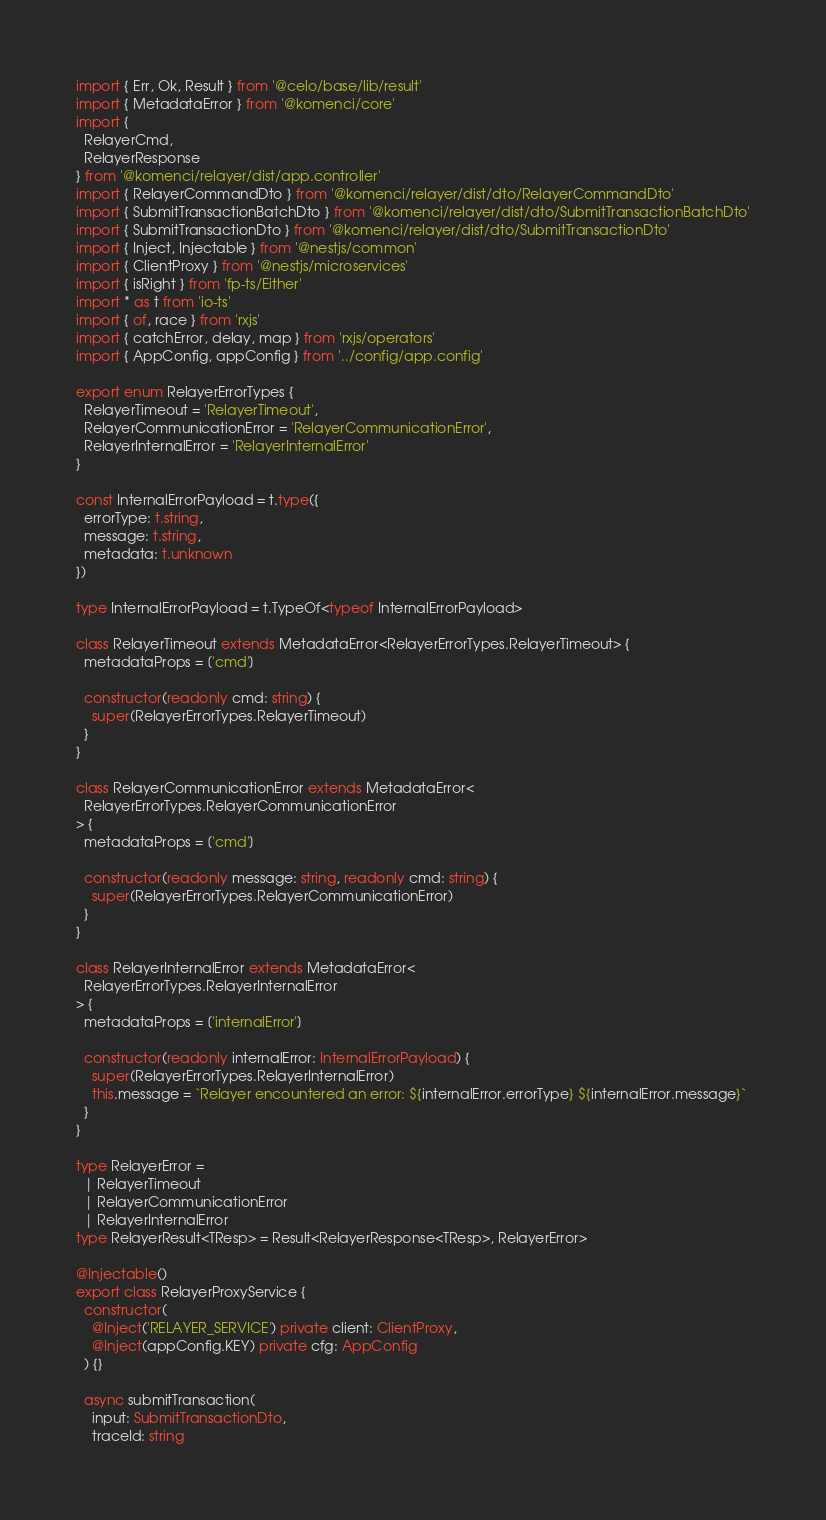Convert code to text. <code><loc_0><loc_0><loc_500><loc_500><_TypeScript_>import { Err, Ok, Result } from '@celo/base/lib/result'
import { MetadataError } from '@komenci/core'
import {
  RelayerCmd,
  RelayerResponse
} from '@komenci/relayer/dist/app.controller'
import { RelayerCommandDto } from '@komenci/relayer/dist/dto/RelayerCommandDto'
import { SubmitTransactionBatchDto } from '@komenci/relayer/dist/dto/SubmitTransactionBatchDto'
import { SubmitTransactionDto } from '@komenci/relayer/dist/dto/SubmitTransactionDto'
import { Inject, Injectable } from '@nestjs/common'
import { ClientProxy } from '@nestjs/microservices'
import { isRight } from 'fp-ts/Either'
import * as t from 'io-ts'
import { of, race } from 'rxjs'
import { catchError, delay, map } from 'rxjs/operators'
import { AppConfig, appConfig } from '../config/app.config'

export enum RelayerErrorTypes {
  RelayerTimeout = 'RelayerTimeout',
  RelayerCommunicationError = 'RelayerCommunicationError',
  RelayerInternalError = 'RelayerInternalError'
}

const InternalErrorPayload = t.type({
  errorType: t.string,
  message: t.string,
  metadata: t.unknown
})

type InternalErrorPayload = t.TypeOf<typeof InternalErrorPayload>

class RelayerTimeout extends MetadataError<RelayerErrorTypes.RelayerTimeout> {
  metadataProps = ['cmd']

  constructor(readonly cmd: string) {
    super(RelayerErrorTypes.RelayerTimeout)
  }
}

class RelayerCommunicationError extends MetadataError<
  RelayerErrorTypes.RelayerCommunicationError
> {
  metadataProps = ['cmd']

  constructor(readonly message: string, readonly cmd: string) {
    super(RelayerErrorTypes.RelayerCommunicationError)
  }
}

class RelayerInternalError extends MetadataError<
  RelayerErrorTypes.RelayerInternalError
> {
  metadataProps = ['internalError']

  constructor(readonly internalError: InternalErrorPayload) {
    super(RelayerErrorTypes.RelayerInternalError)
    this.message = `Relayer encountered an error: ${internalError.errorType} ${internalError.message}`
  }
}

type RelayerError =
  | RelayerTimeout
  | RelayerCommunicationError
  | RelayerInternalError
type RelayerResult<TResp> = Result<RelayerResponse<TResp>, RelayerError>

@Injectable()
export class RelayerProxyService {
  constructor(
    @Inject('RELAYER_SERVICE') private client: ClientProxy,
    @Inject(appConfig.KEY) private cfg: AppConfig
  ) {}

  async submitTransaction(
    input: SubmitTransactionDto,
    traceId: string</code> 